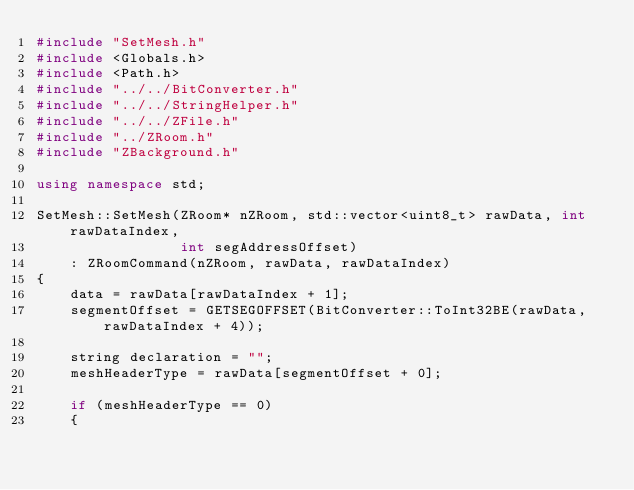Convert code to text. <code><loc_0><loc_0><loc_500><loc_500><_C++_>#include "SetMesh.h"
#include <Globals.h>
#include <Path.h>
#include "../../BitConverter.h"
#include "../../StringHelper.h"
#include "../../ZFile.h"
#include "../ZRoom.h"
#include "ZBackground.h"

using namespace std;

SetMesh::SetMesh(ZRoom* nZRoom, std::vector<uint8_t> rawData, int rawDataIndex,
                 int segAddressOffset)
	: ZRoomCommand(nZRoom, rawData, rawDataIndex)
{
	data = rawData[rawDataIndex + 1];
	segmentOffset = GETSEGOFFSET(BitConverter::ToInt32BE(rawData, rawDataIndex + 4));

	string declaration = "";
	meshHeaderType = rawData[segmentOffset + 0];

	if (meshHeaderType == 0)
	{</code> 